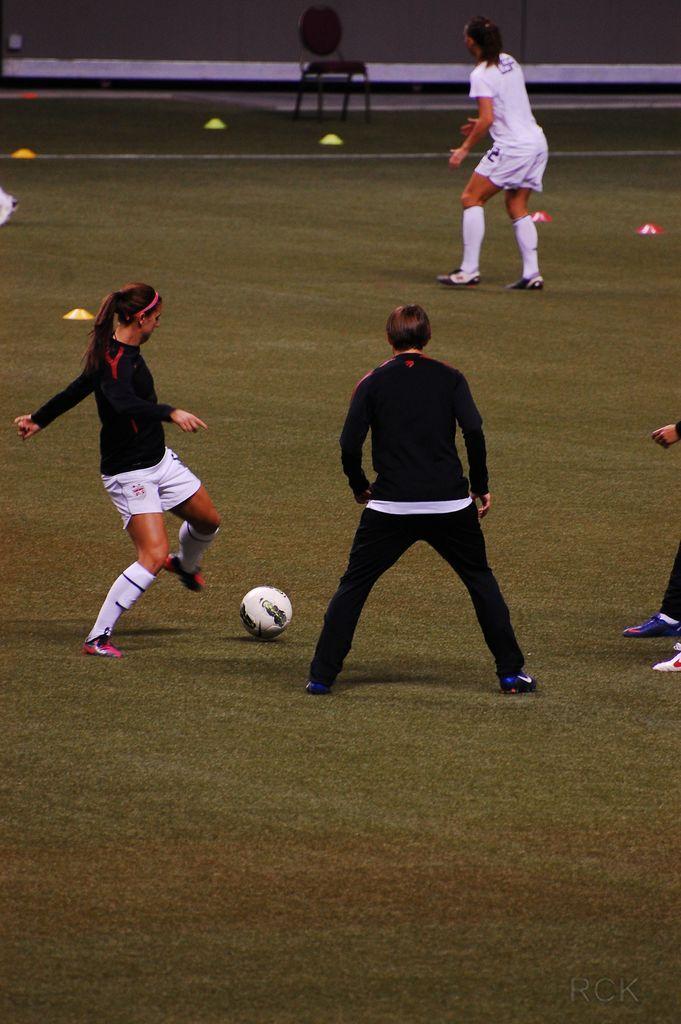Describe this image in one or two sentences. On the left there is a woman , her hair is short, she is playing football. In the middle there is a man he wear black t shirt and trouser. On the right there is a woman she wear white t shirt and shoes. In the middle there is a chair. This is a football stadium. 